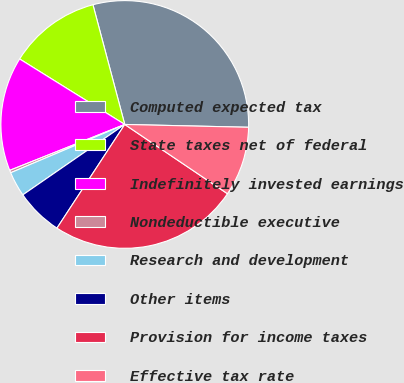<chart> <loc_0><loc_0><loc_500><loc_500><pie_chart><fcel>Computed expected tax<fcel>State taxes net of federal<fcel>Indefinitely invested earnings<fcel>Nondeductible executive<fcel>Research and development<fcel>Other items<fcel>Provision for income taxes<fcel>Effective tax rate<nl><fcel>29.5%<fcel>12.0%<fcel>14.91%<fcel>0.33%<fcel>3.25%<fcel>6.16%<fcel>24.78%<fcel>9.08%<nl></chart> 